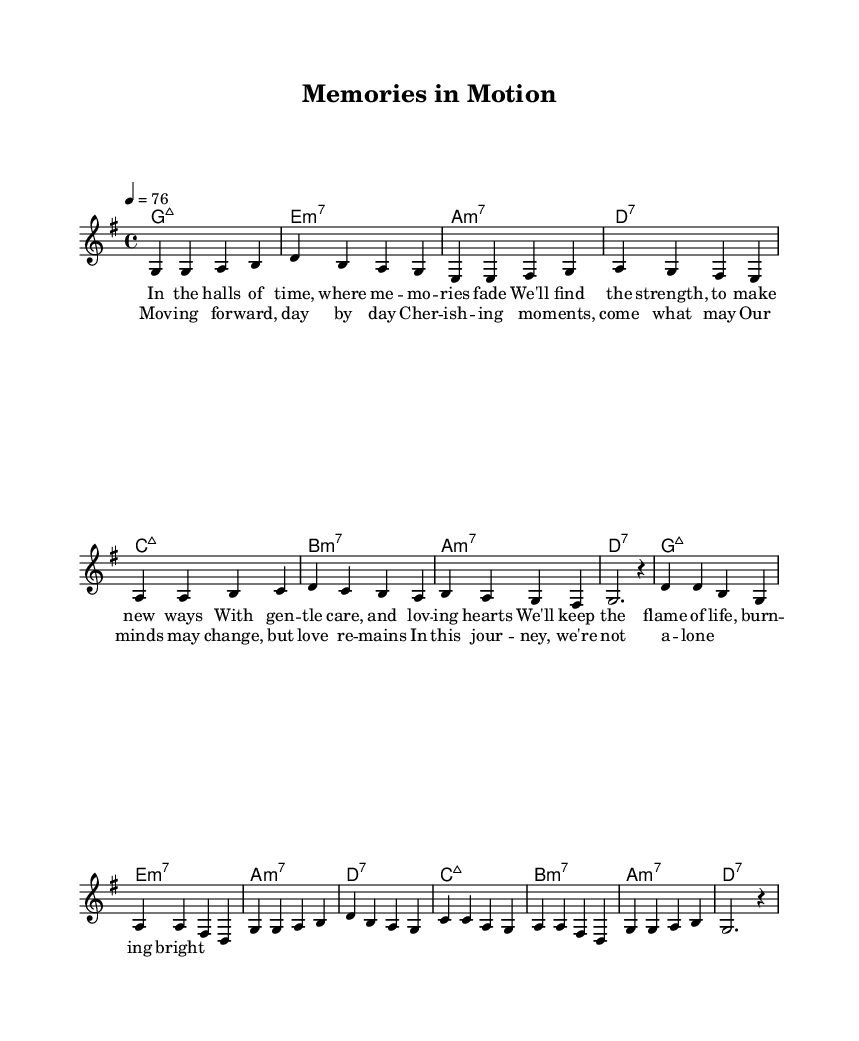What is the key signature of this music? The key signature is G major, which has one sharp (F#). This can be observed at the beginning of the score, where the clef and key signature are indicated.
Answer: G major What is the time signature of the piece? The time signature is 4/4, as indicated near the beginning of the sheet music. This means there are four beats in each measure, and a quarter note receives one beat.
Answer: 4/4 What is the tempo marking for this music? The tempo marking is 76 beats per minute, which indicates how fast the music should be played. This is shown in the tempo directive after the time signature.
Answer: 76 How many measures are in the verse? The verse consists of 8 measures, as counted from the beginning of the verse section up to the end of the eighth measure. Each measure is separated by a vertical line.
Answer: 8 What type of seventh chord is used in the first measure? The first measure contains a G major seventh chord, which is indicated by "maj7" next to the chord name in the harmonies section. The "maj" refers to major and "7" indicates it's a seventh chord.
Answer: G major seventh What is the main theme addressed in the lyrics? The lyrics focus on memory care, love, and the passage of time, as they speak about cherishing moments and finding strength in caring relationships. By looking through the lyrics, one can infer the central theme of support and remembering love through challenges.
Answer: Memory care and love How does the choruses' message connect to cognitive health? The chorus emphasizes cherishing moments and the enduring nature of love despite cognitive changes. This reflects the importance of emotional connections, which can positively impact cognitive health in individuals. The lyrics highlight that love remains a constant support through cognitive challenges.
Answer: Cherishing moments 